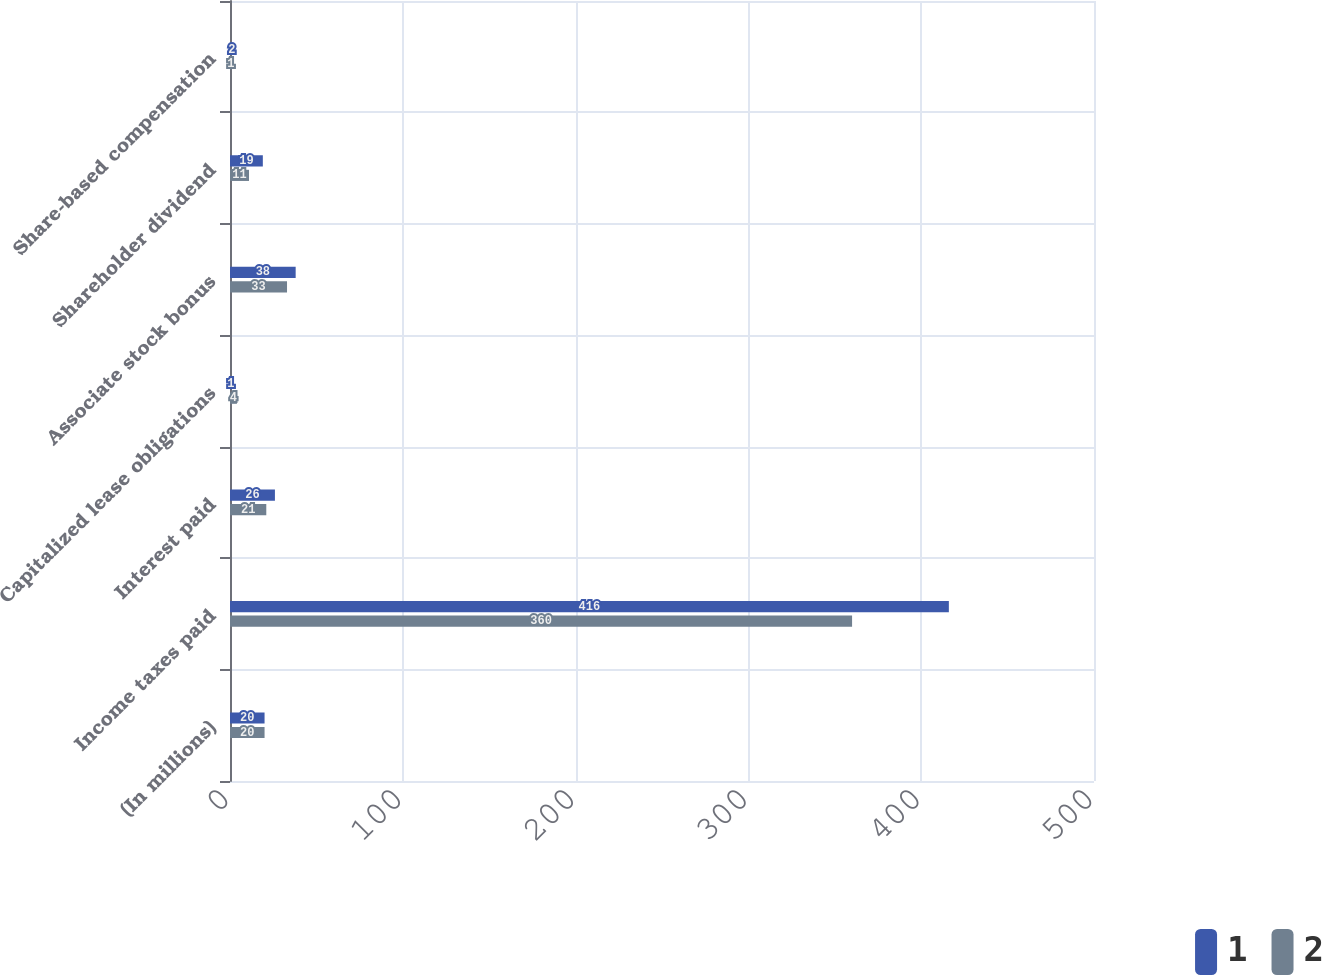Convert chart. <chart><loc_0><loc_0><loc_500><loc_500><stacked_bar_chart><ecel><fcel>(In millions)<fcel>Income taxes paid<fcel>Interest paid<fcel>Capitalized lease obligations<fcel>Associate stock bonus<fcel>Shareholder dividend<fcel>Share-based compensation<nl><fcel>1<fcel>20<fcel>416<fcel>26<fcel>1<fcel>38<fcel>19<fcel>2<nl><fcel>2<fcel>20<fcel>360<fcel>21<fcel>4<fcel>33<fcel>11<fcel>1<nl></chart> 